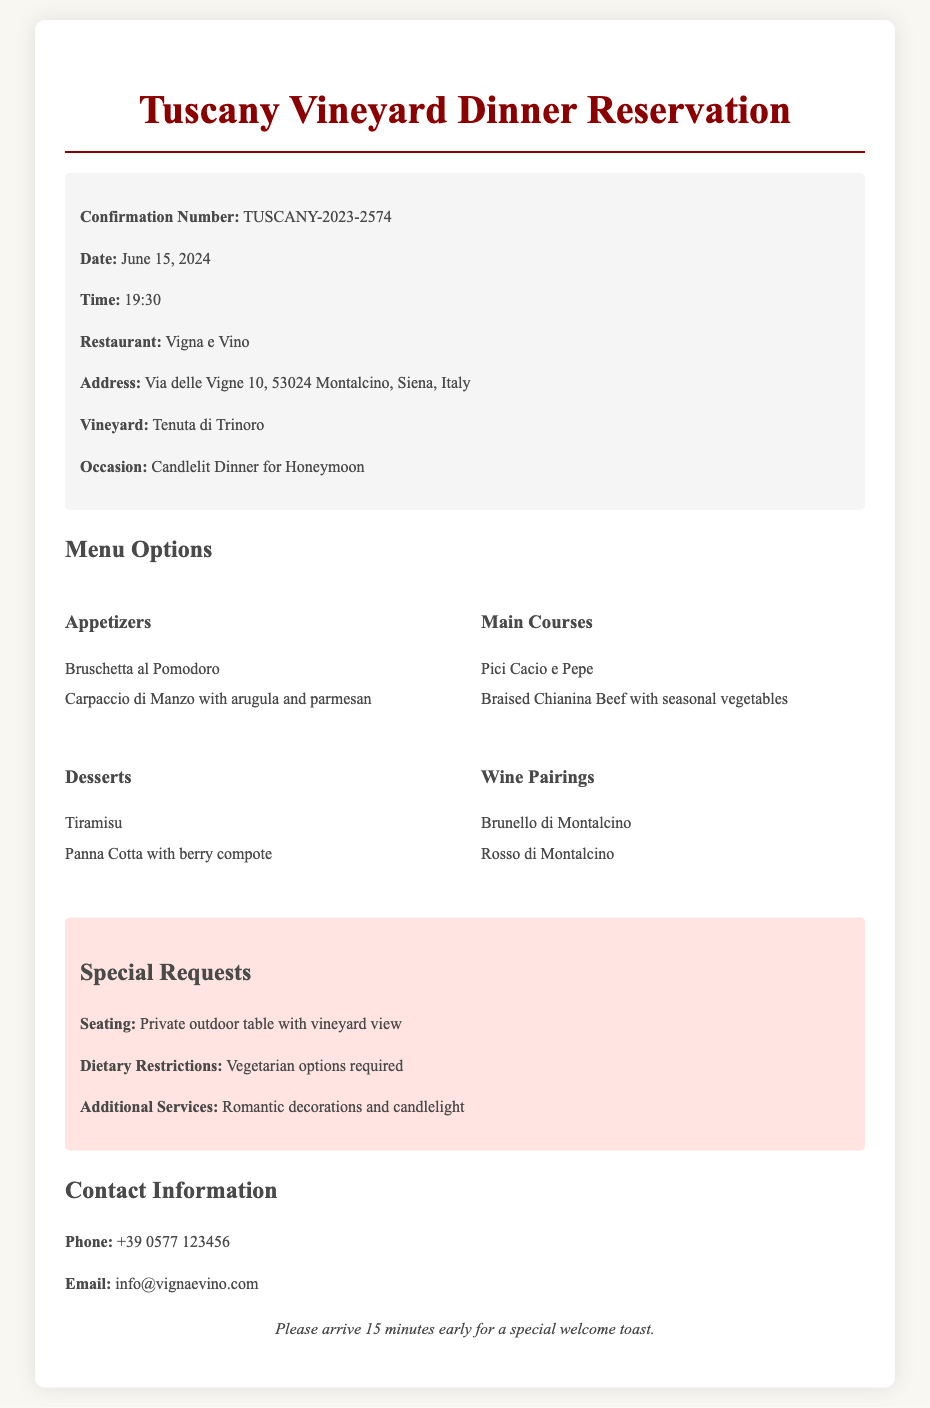what is the confirmation number? The confirmation number is a unique identifier for the reservation, which is listed as "TUSCANY-2023-2574."
Answer: TUSCANY-2023-2574 what is the date of the reservation? The document specifies the date of the reservation as "June 15, 2024."
Answer: June 15, 2024 what is the occasion for the dinner? The occasion given in the document is "Candlelit Dinner for Honeymoon."
Answer: Candlelit Dinner for Honeymoon what type of seating is requested? The special requests section mentions a specific seating request for a "Private outdoor table with vineyard view."
Answer: Private outdoor table with vineyard view which dessert options are available? Candidates can find dessert options listed under the menu section, which includes "Tiramisu" and "Panna Cotta with berry compote."
Answer: Tiramisu and Panna Cotta with berry compote what are the wine pairings offered? The menu options include wine pairings, specifically "Brunello di Montalcino" and "Rosso di Montalcino."
Answer: Brunello di Montalcino and Rosso di Montalcino what time is the dinner reservation? The document lists the time of the reservation as "19:30."
Answer: 19:30 what additional services are requested for the dinner? The special requests indicate "Romantic decorations and candlelight" as additional services.
Answer: Romantic decorations and candlelight 